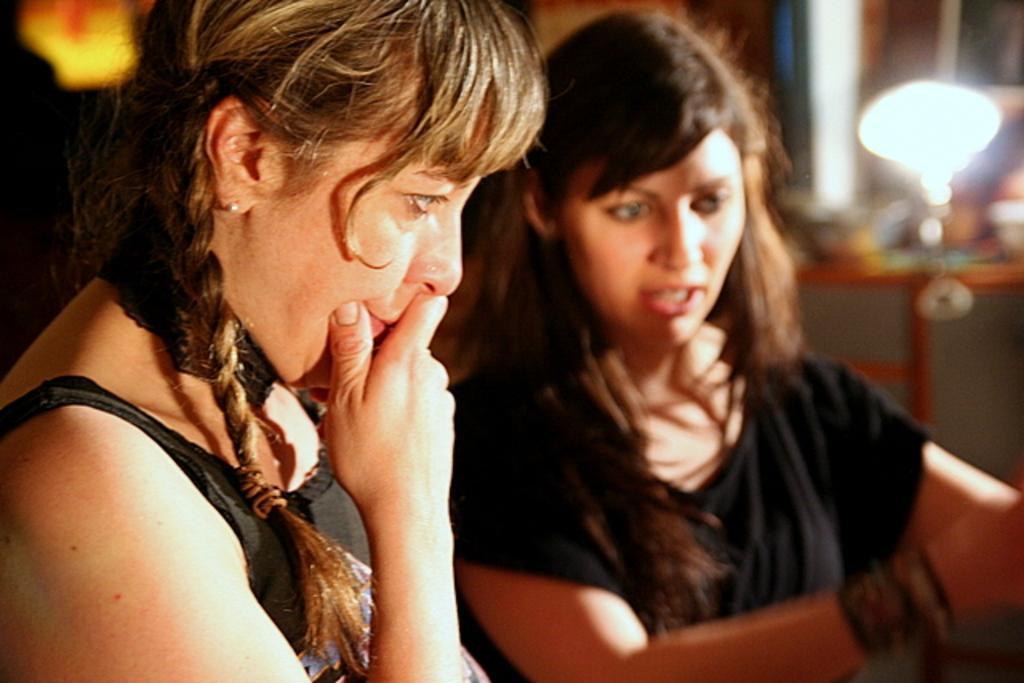Could you give a brief overview of what you see in this image? In this picture I can see couple of woman and I can see a light and few items on the table in the background. 